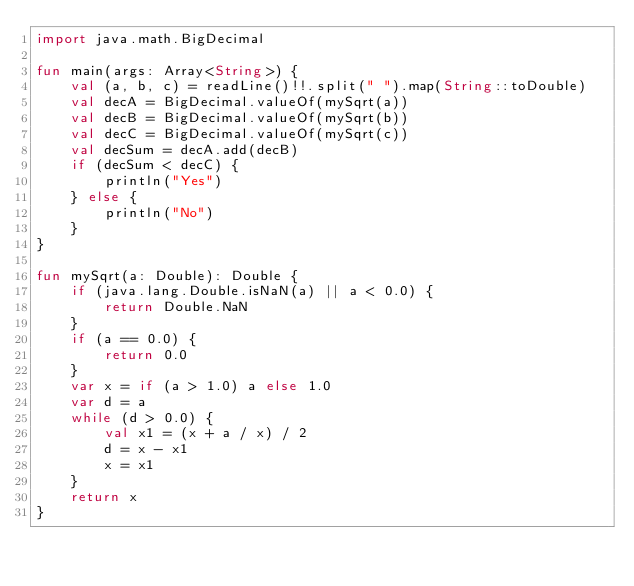Convert code to text. <code><loc_0><loc_0><loc_500><loc_500><_Kotlin_>import java.math.BigDecimal

fun main(args: Array<String>) {
    val (a, b, c) = readLine()!!.split(" ").map(String::toDouble)
    val decA = BigDecimal.valueOf(mySqrt(a))
    val decB = BigDecimal.valueOf(mySqrt(b))
    val decC = BigDecimal.valueOf(mySqrt(c))
    val decSum = decA.add(decB)
    if (decSum < decC) {
        println("Yes")
    } else {
        println("No")
    }
}

fun mySqrt(a: Double): Double {
    if (java.lang.Double.isNaN(a) || a < 0.0) {
        return Double.NaN
    }
    if (a == 0.0) {
        return 0.0
    }
    var x = if (a > 1.0) a else 1.0
    var d = a
    while (d > 0.0) {
        val x1 = (x + a / x) / 2
        d = x - x1
        x = x1
    }
    return x
}
</code> 